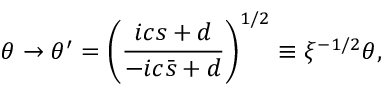Convert formula to latex. <formula><loc_0><loc_0><loc_500><loc_500>\theta \rightarrow \theta ^ { \prime } = \left ( \frac { i c s + d } { - i c \bar { s } + d } \right ) ^ { 1 / 2 } \equiv \xi ^ { - 1 / 2 } \theta ,</formula> 